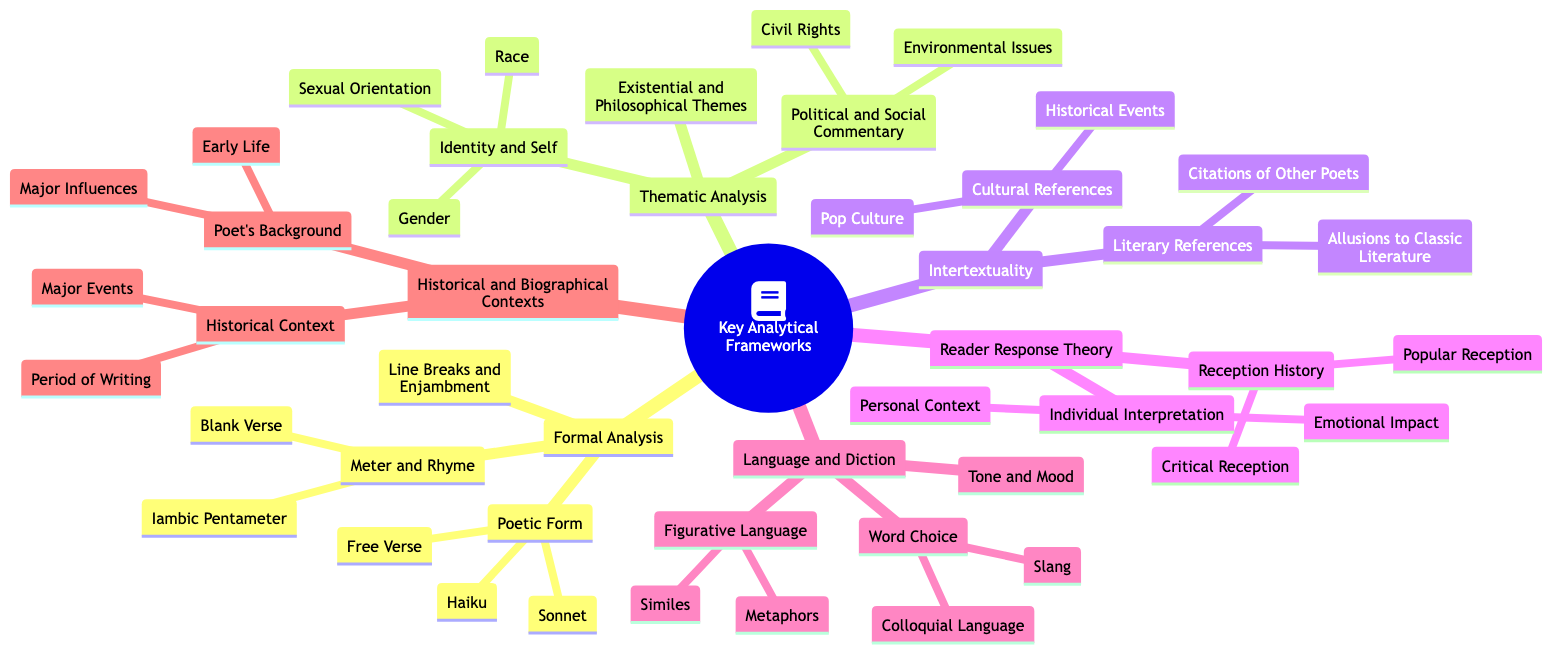What are the three categories under "Key Analytical Frameworks"? The diagram lists "Formal Analysis," "Thematic Analysis," and "Intertextuality" as the three primary categories. These are connected directly to the root node and represent different frameworks for analysis.
Answer: Formal Analysis, Thematic Analysis, Intertextuality How many types of poetic forms are listed under "Formal Analysis"? Under "Poetic Form," there are three specific types mentioned: "Free Verse," "Sonnet," and "Haiku." By counting these entries, we find a total of three.
Answer: 3 What are two themes found under "Identity and Self" in "Thematic Analysis"? The "Identity and Self" section includes "Race," "Gender," and "Sexual Orientation." Together, "Race" and "Gender" represent two themes that can be examined.
Answer: Race, Gender What type of analysis focuses on personal context and emotional impact? The "Individual Interpretation" section in "Reader Response Theory" specifically centers on "Personal Context" and "Emotional Impact," making it the relevant analytical framework.
Answer: Reader Response Theory Which references are included under "Cultural References"? The "Cultural References" node includes "Pop Culture" and "Historical Events." These elements highlight the connections to wider cultural contexts in poetry.
Answer: Pop Culture, Historical Events How many types of language-related analyses are outlined in "Language and Diction"? The section "Language and Diction" contains three main types of analyses: "Word Choice," "Figurative Language," and "Tone and Mood." Therefore, the total count is three.
Answer: 3 What does the "Historical Context" node encompass? The "Historical Context" node includes "Period of Writing" and "Major Events," thus providing two distinct areas for historical analysis of poetry.
Answer: Period of Writing, Major Events Which specific meter is mentioned under "Meter and Rhyme"? The "Meter and Rhyme" section includes "Iambic Pentameter" as a specific type of meter. This detail highlights a particular area of formal analysis in poetry.
Answer: Iambic Pentameter What is one example of a literary reference mentioned? Within "Literary References," "Allusions to Classic Literature" is given as an example, illustrating how poems can draw connections to other literary works.
Answer: Allusions to Classic Literature 